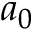Convert formula to latex. <formula><loc_0><loc_0><loc_500><loc_500>a _ { 0 }</formula> 